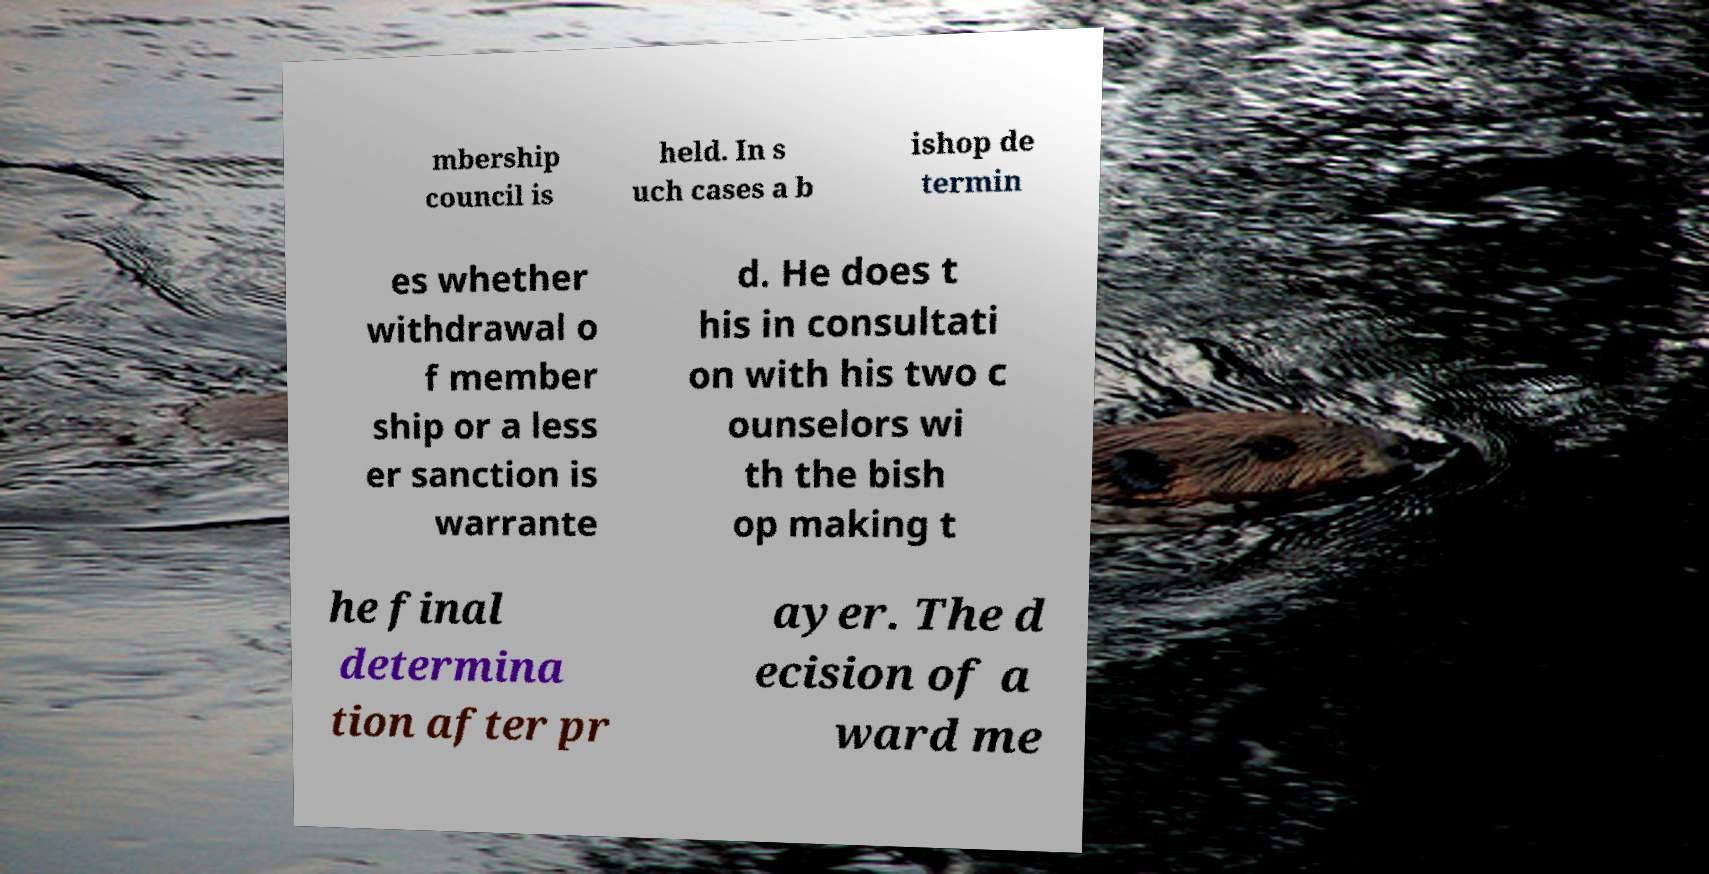I need the written content from this picture converted into text. Can you do that? mbership council is held. In s uch cases a b ishop de termin es whether withdrawal o f member ship or a less er sanction is warrante d. He does t his in consultati on with his two c ounselors wi th the bish op making t he final determina tion after pr ayer. The d ecision of a ward me 